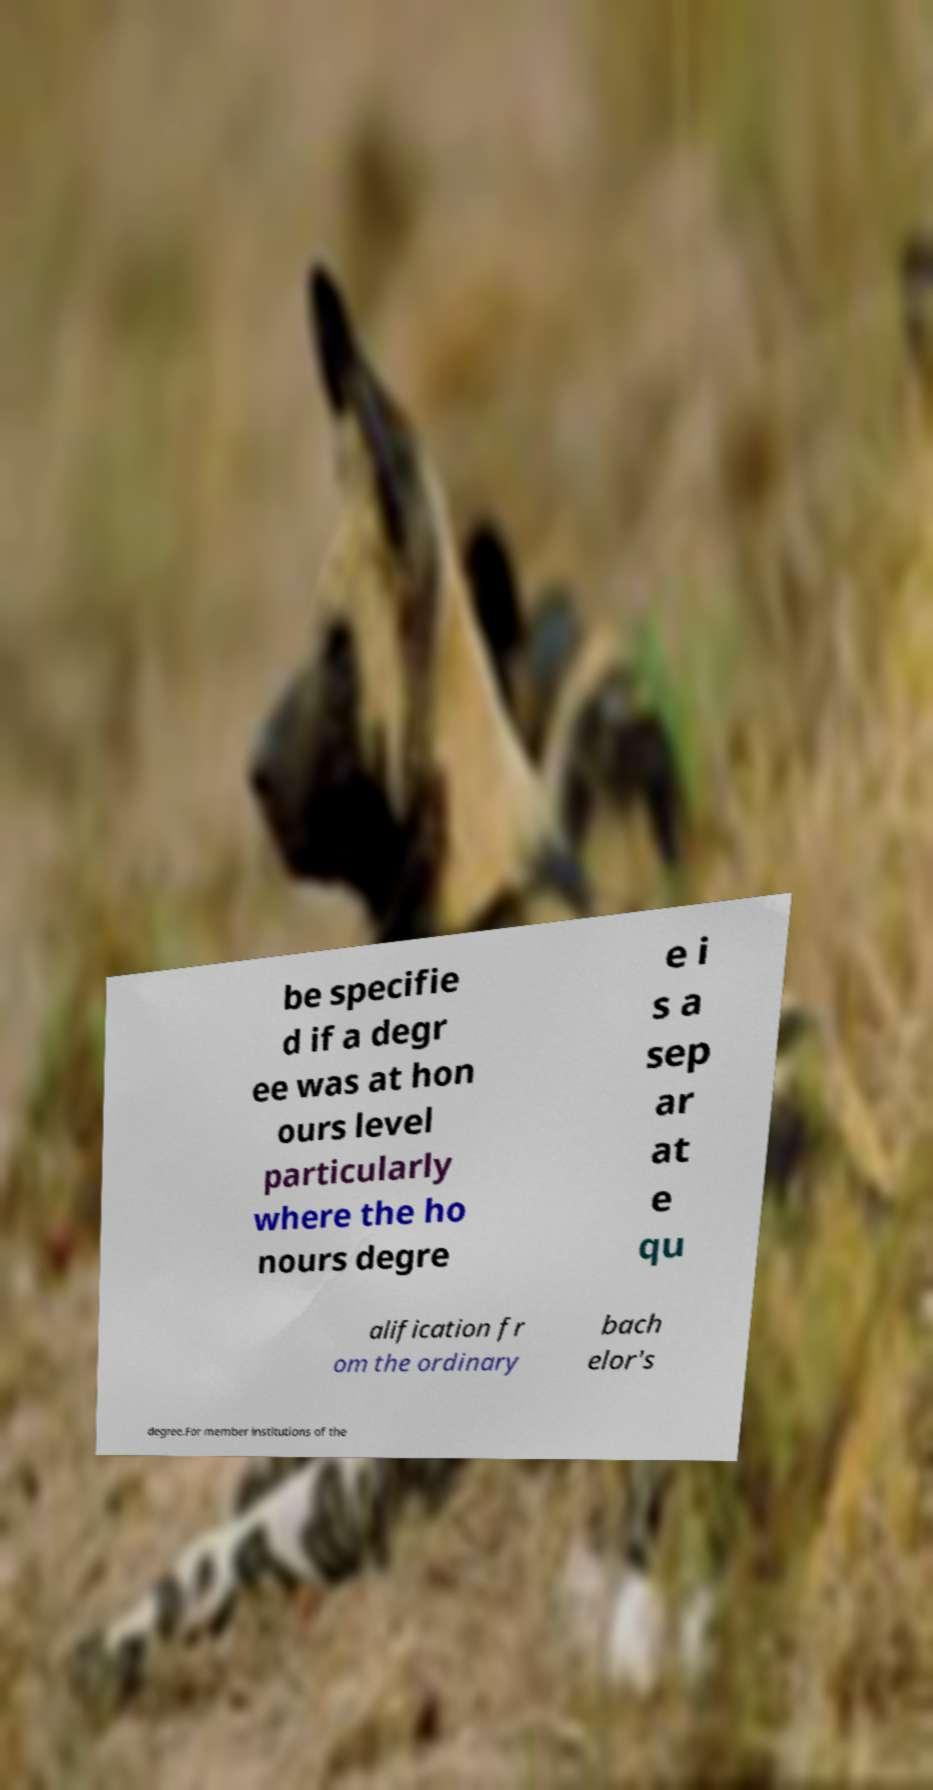Could you extract and type out the text from this image? be specifie d if a degr ee was at hon ours level particularly where the ho nours degre e i s a sep ar at e qu alification fr om the ordinary bach elor's degree.For member institutions of the 